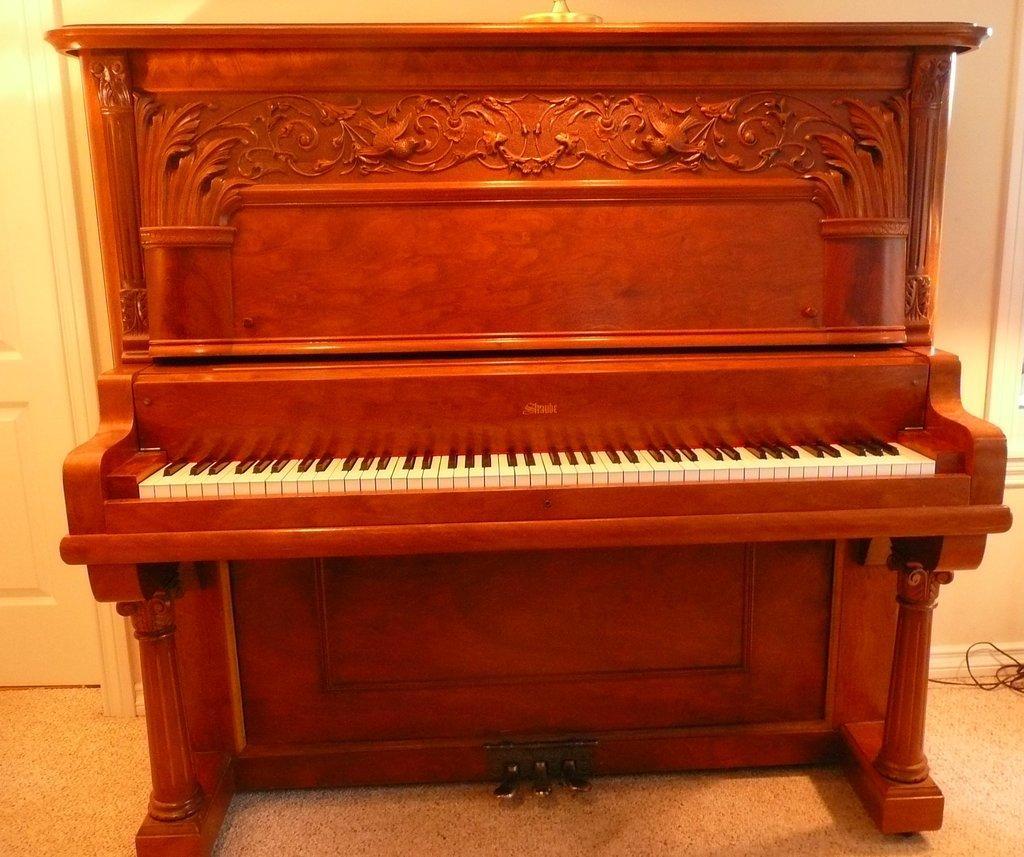Describe this image in one or two sentences. This picture shows a piano 